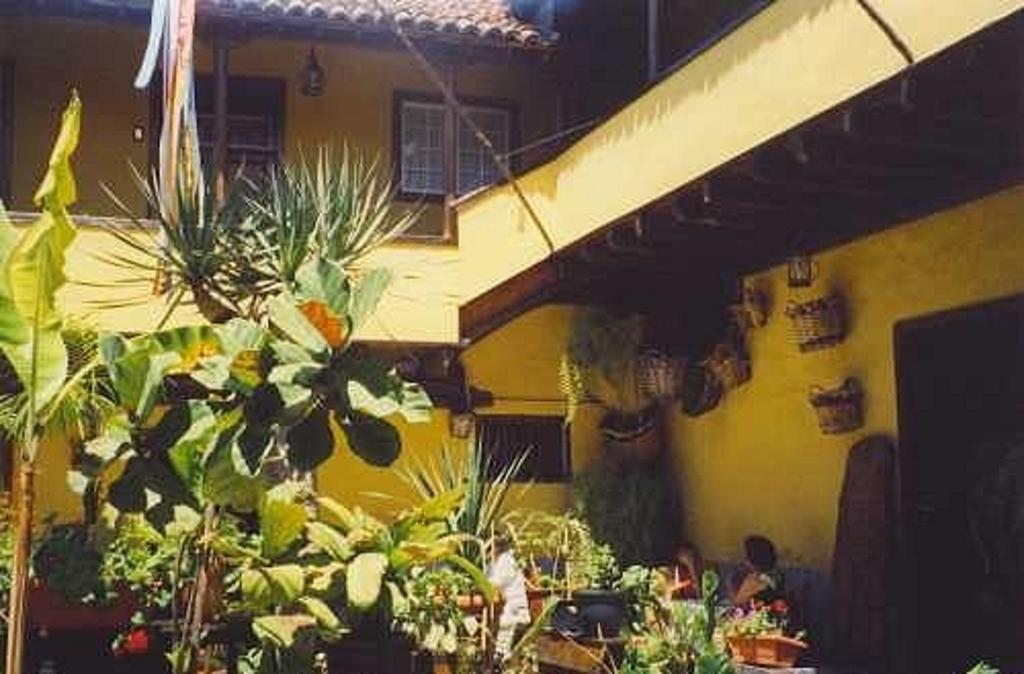What type of structure is visible in the image? There is a building in the image. What type of vegetation can be seen in the image? There are plants and trees in the image. What objects are present in the image that might be used for carrying or storing items? There are baskets in the image. What architectural feature allows light to enter the building and provides a view of the outdoors? There are windows in the image. What direction is the whip pointing in the image? There is no whip present in the image, so it is not possible to determine the direction it might be pointing. 